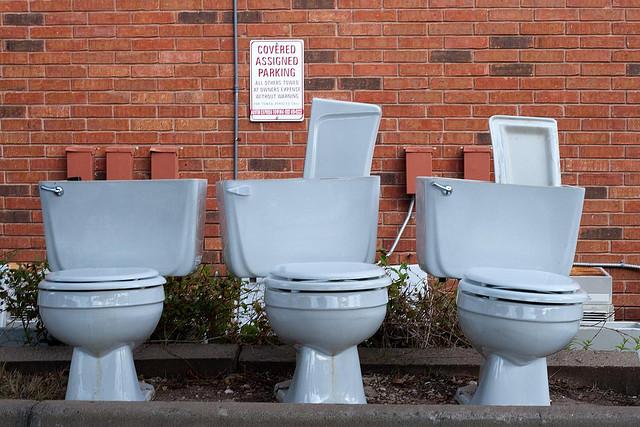What does the sign say?
Give a very brief answer. Covered assigned parking. What is the building made of?
Answer briefly. Brick. How many toilets are there?
Give a very brief answer. 3. 